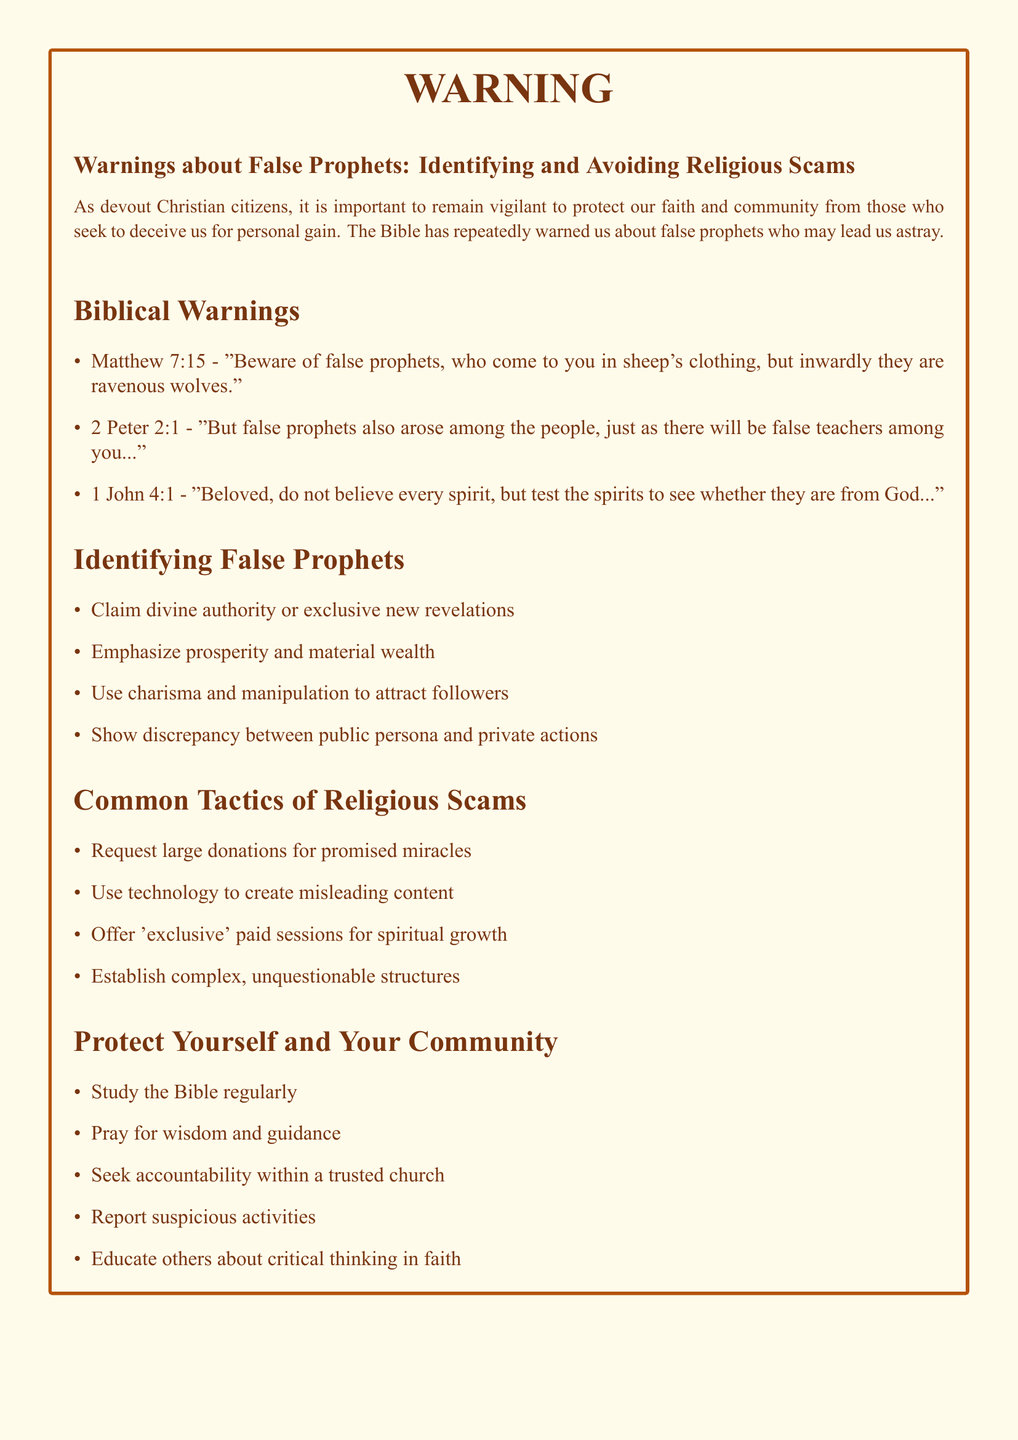What is the title of the document? The title is presented clearly at the beginning of the document, signifying its main focus.
Answer: Warnings about False Prophets: Identifying and Avoiding Religious Scams How many biblical warnings are listed? The document contains a specific section dedicated to biblical warnings, which includes an enumerated list.
Answer: 3 Which book of the Bible does the first warning come from? The document includes specific references for each biblical warning, indicating their sources.
Answer: Matthew What is one tactic used by religious scams? The document outlines specific tactics commonly used by those perpetrating religious scams in a clear list.
Answer: Request large donations for promised miracles What should one do to protect oneself and the community? The document provides actionable advice under a specific section designed to help readers safeguard their faith and community.
Answer: Study the Bible regularly What is the focus of 1 John 4:1? The reference highlights a specific warning about belief and discernment regarding spiritual matters, reflecting core themes in the document.
Answer: Test the spirits to see whether they are from God What character trait is commonly used by false prophets? The document describes specific behaviors that characterize false prophets, providing insight into their manipulative nature.
Answer: Charisma and manipulation What is one way to seek accountability within a trusted church? The document emphasizes the importance of community and accountability in faith practices through a brief list.
Answer: Seek accountability within a trusted church 